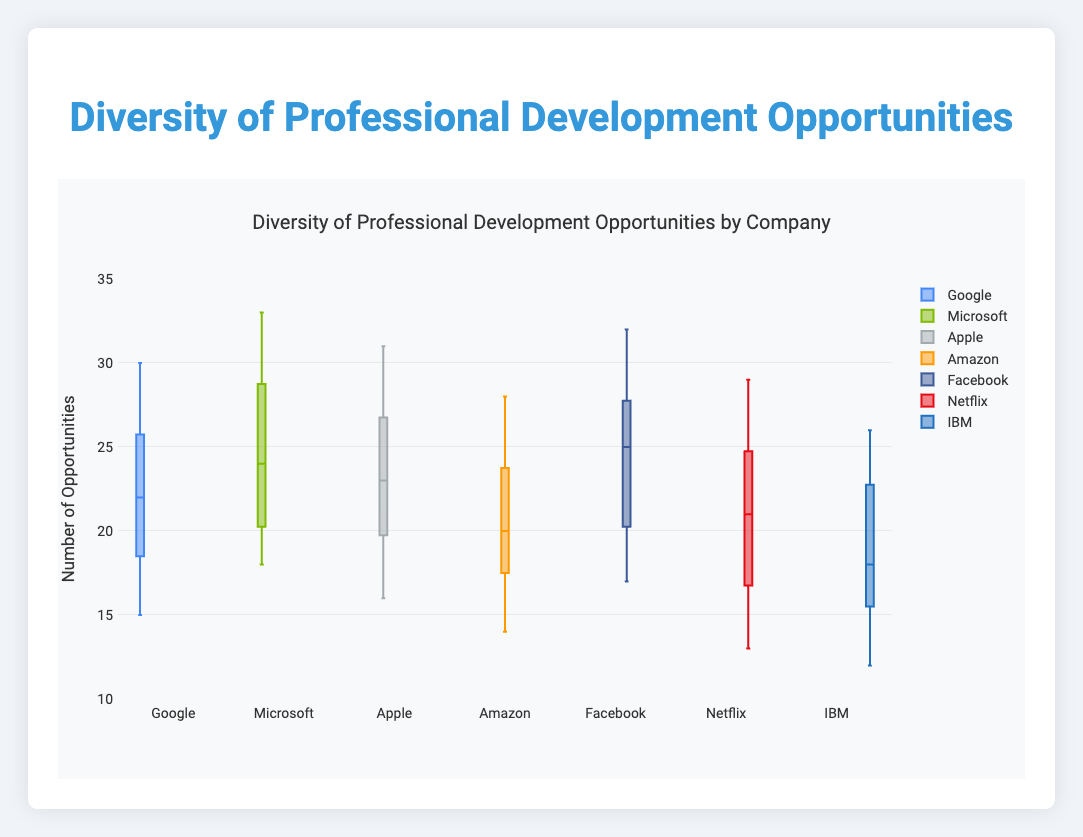What's the range of diversity of professional development opportunities for Google? The range is the difference between the maximum and minimum values. For Google, the maximum value is 30, and the minimum value is 15. So, the range is 30 - 15.
Answer: 15 Which company has the highest median number of opportunities? The median is the middle value of a data set when it is ordered. For Microsoft, the median is 24; for Google, it is 22; for Apple, it is 23; for Amazon, it is 20; for Facebook, it is 25; for Netflix, it is 21; for IBM, it is 18. Facebook has the highest median value.
Answer: Facebook How do the interquartile ranges (IQR) of Google and Apple compare? The IQR is the difference between the third quartile (Q3) and the first quartile (Q1). For Google, Q3 is 26, and Q1 is 18, so the IQR is 26 - 18 = 8. For Apple, Q3 is 27, and Q1 is 19, so the IQR is 27 - 19 = 8. Both Google and Apple have the same IQR.
Answer: They are the same Which company has the smallest upper whisker value? The upper whisker of a box plot typically extends to the maximum data point unless there are outliers. Google: 30, Microsoft: 33, Apple: 31, Amazon: 28, Facebook: 32, Netflix: 29, IBM: 26. IBM has the smallest upper whisker value.
Answer: IBM What is the median number of opportunities for Netflix? The box plot shows the median as the central line in the box. For Netflix, this value is 21.
Answer: 21 Between which two companies is there the largest difference in their medians? The medians are Google: 22, Microsoft: 24, Apple: 23, Amazon: 20, Facebook: 25, Netflix: 21, IBM: 18. The largest difference in medians is between Facebook (25) and IBM (18), resulting in a difference of 7.
Answer: Facebook and IBM How does Netflix's median compare to Amazon's median? Netflix's median is 21, and Amazon's median is 20. The difference is 1, with Netflix having a slightly higher median.
Answer: Netflix has a higher median by 1 Which company has the widest box (IQR) in the plot? The box width is the IQR, and it is the difference between Q3 and Q1. By comparing all companies' IQRs: Google (8), Microsoft (9), Apple (8), Amazon (9), Facebook (9), Netflix (8), IBM (8). Microsoft, Amazon, and Facebook all share the widest IQR.
Answer: Microsoft, Amazon, and Facebook 